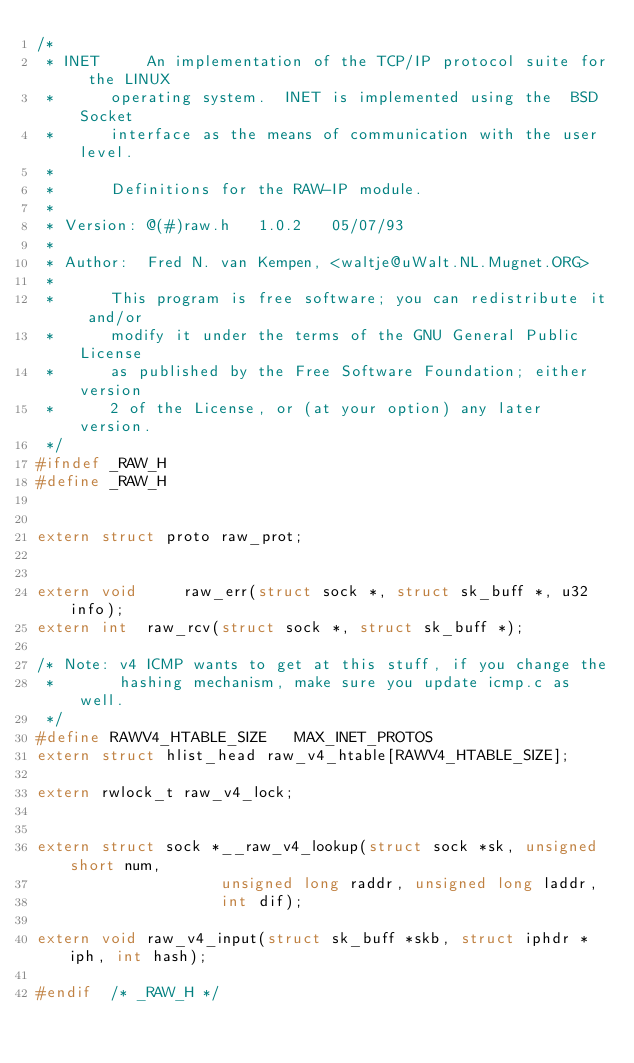Convert code to text. <code><loc_0><loc_0><loc_500><loc_500><_C_>/*
 * INET		An implementation of the TCP/IP protocol suite for the LINUX
 *		operating system.  INET is implemented using the  BSD Socket
 *		interface as the means of communication with the user level.
 *
 *		Definitions for the RAW-IP module.
 *
 * Version:	@(#)raw.h	1.0.2	05/07/93
 *
 * Author:	Fred N. van Kempen, <waltje@uWalt.NL.Mugnet.ORG>
 *
 *		This program is free software; you can redistribute it and/or
 *		modify it under the terms of the GNU General Public License
 *		as published by the Free Software Foundation; either version
 *		2 of the License, or (at your option) any later version.
 */
#ifndef _RAW_H
#define _RAW_H


extern struct proto raw_prot;


extern void 	raw_err(struct sock *, struct sk_buff *, u32 info);
extern int 	raw_rcv(struct sock *, struct sk_buff *);

/* Note: v4 ICMP wants to get at this stuff, if you change the
 *       hashing mechanism, make sure you update icmp.c as well.
 */
#define RAWV4_HTABLE_SIZE	MAX_INET_PROTOS
extern struct hlist_head raw_v4_htable[RAWV4_HTABLE_SIZE];

extern rwlock_t raw_v4_lock;


extern struct sock *__raw_v4_lookup(struct sock *sk, unsigned short num,
				    unsigned long raddr, unsigned long laddr,
				    int dif);

extern void raw_v4_input(struct sk_buff *skb, struct iphdr *iph, int hash);

#endif	/* _RAW_H */
</code> 